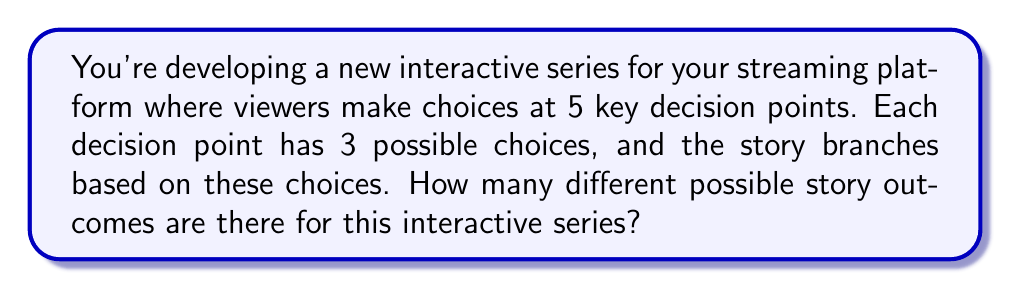Can you answer this question? Let's approach this step-by-step:

1) In this interactive series, there are 5 decision points.

2) At each decision point, the viewer has 3 choices.

3) Each choice leads to a different branch of the story.

4) To calculate the total number of possible outcomes, we need to consider the Multiplication Principle of Counting.

5) The Multiplication Principle states that if we have $n$ independent events, and each event $i$ has $m_i$ possible outcomes, then the total number of possible outcomes for all events is the product of the number of outcomes for each event.

6) In this case, we have 5 independent events (decision points), each with 3 possible outcomes (choices).

7) Therefore, the total number of possible outcomes is:

   $$3 \times 3 \times 3 \times 3 \times 3 = 3^5$$

8) We can calculate this:

   $$3^5 = 3 \times 3 \times 3 \times 3 \times 3 = 243$$

Thus, there are 243 different possible story outcomes for this interactive series.
Answer: 243 